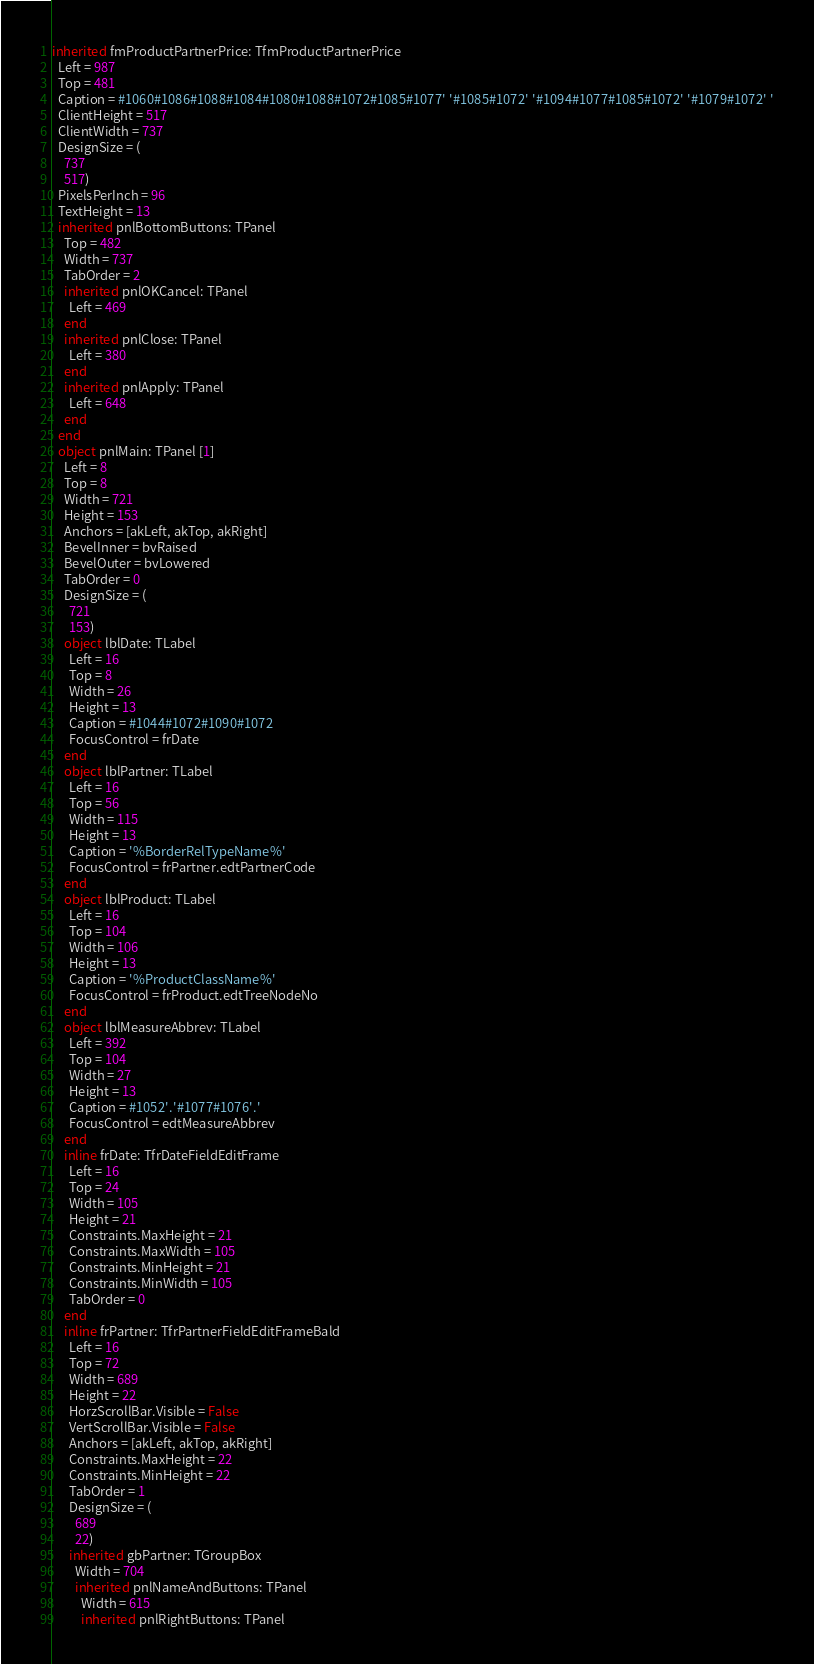Convert code to text. <code><loc_0><loc_0><loc_500><loc_500><_Pascal_>inherited fmProductPartnerPrice: TfmProductPartnerPrice
  Left = 987
  Top = 481
  Caption = #1060#1086#1088#1084#1080#1088#1072#1085#1077' '#1085#1072' '#1094#1077#1085#1072' '#1079#1072' '
  ClientHeight = 517
  ClientWidth = 737
  DesignSize = (
    737
    517)
  PixelsPerInch = 96
  TextHeight = 13
  inherited pnlBottomButtons: TPanel
    Top = 482
    Width = 737
    TabOrder = 2
    inherited pnlOKCancel: TPanel
      Left = 469
    end
    inherited pnlClose: TPanel
      Left = 380
    end
    inherited pnlApply: TPanel
      Left = 648
    end
  end
  object pnlMain: TPanel [1]
    Left = 8
    Top = 8
    Width = 721
    Height = 153
    Anchors = [akLeft, akTop, akRight]
    BevelInner = bvRaised
    BevelOuter = bvLowered
    TabOrder = 0
    DesignSize = (
      721
      153)
    object lblDate: TLabel
      Left = 16
      Top = 8
      Width = 26
      Height = 13
      Caption = #1044#1072#1090#1072
      FocusControl = frDate
    end
    object lblPartner: TLabel
      Left = 16
      Top = 56
      Width = 115
      Height = 13
      Caption = '%BorderRelTypeName%'
      FocusControl = frPartner.edtPartnerCode
    end
    object lblProduct: TLabel
      Left = 16
      Top = 104
      Width = 106
      Height = 13
      Caption = '%ProductClassName%'
      FocusControl = frProduct.edtTreeNodeNo
    end
    object lblMeasureAbbrev: TLabel
      Left = 392
      Top = 104
      Width = 27
      Height = 13
      Caption = #1052'.'#1077#1076'.'
      FocusControl = edtMeasureAbbrev
    end
    inline frDate: TfrDateFieldEditFrame
      Left = 16
      Top = 24
      Width = 105
      Height = 21
      Constraints.MaxHeight = 21
      Constraints.MaxWidth = 105
      Constraints.MinHeight = 21
      Constraints.MinWidth = 105
      TabOrder = 0
    end
    inline frPartner: TfrPartnerFieldEditFrameBald
      Left = 16
      Top = 72
      Width = 689
      Height = 22
      HorzScrollBar.Visible = False
      VertScrollBar.Visible = False
      Anchors = [akLeft, akTop, akRight]
      Constraints.MaxHeight = 22
      Constraints.MinHeight = 22
      TabOrder = 1
      DesignSize = (
        689
        22)
      inherited gbPartner: TGroupBox
        Width = 704
        inherited pnlNameAndButtons: TPanel
          Width = 615
          inherited pnlRightButtons: TPanel</code> 